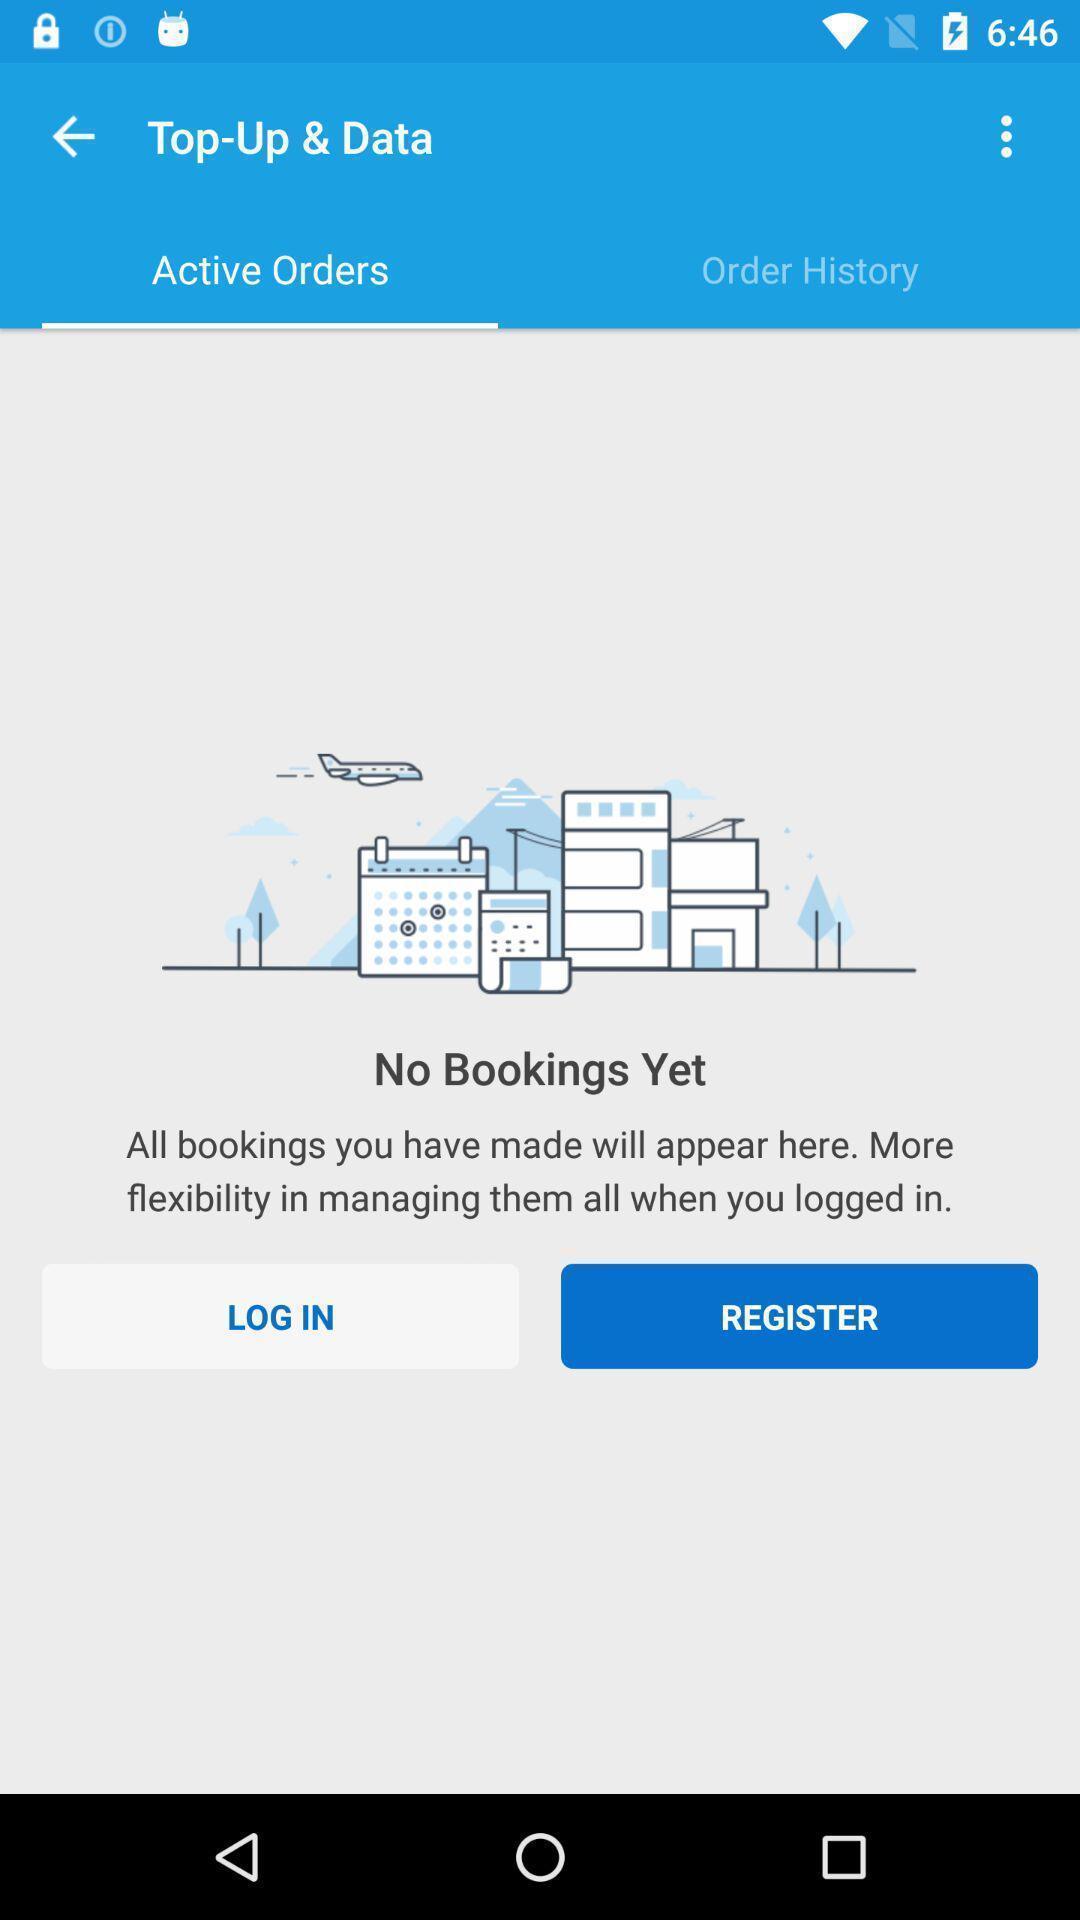Describe the key features of this screenshot. Welcome page of travel app. 